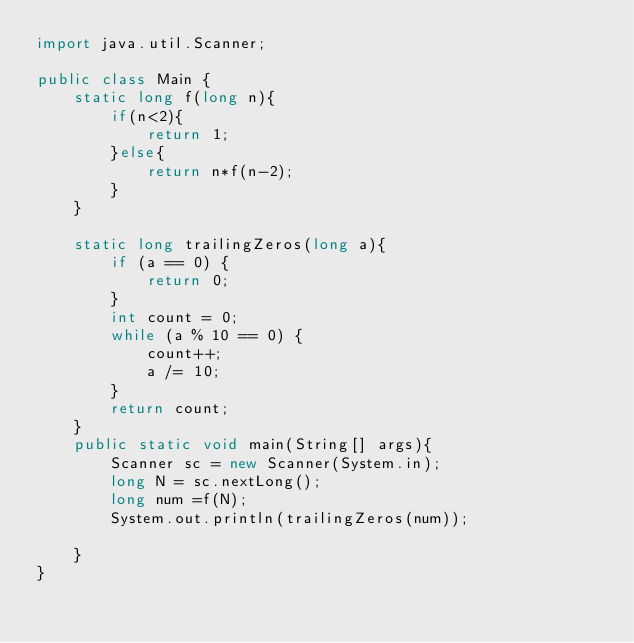Convert code to text. <code><loc_0><loc_0><loc_500><loc_500><_Java_>import java.util.Scanner;

public class Main {
    static long f(long n){
        if(n<2){
            return 1;
        }else{
            return n*f(n-2);
        }
    }

    static long trailingZeros(long a){
        if (a == 0) {
            return 0;
        }
        int count = 0;
        while (a % 10 == 0) {
            count++;
            a /= 10;
        }
        return count;
    }
    public static void main(String[] args){
        Scanner sc = new Scanner(System.in);
        long N = sc.nextLong();
        long num =f(N);
        System.out.println(trailingZeros(num));

    }
}
</code> 